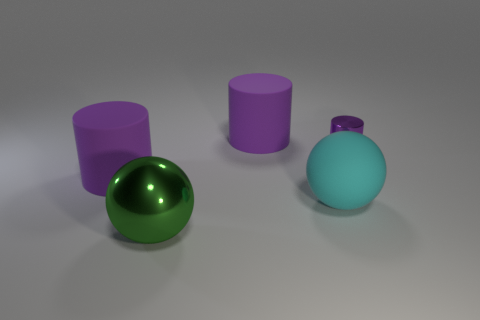There is a cyan rubber object; are there any cylinders to the left of it?
Ensure brevity in your answer.  Yes. How many other objects are the same shape as the tiny purple metal thing?
Offer a terse response. 2. The rubber ball that is the same size as the metal sphere is what color?
Provide a short and direct response. Cyan. Is the number of tiny purple things behind the green thing less than the number of purple cylinders that are to the left of the cyan thing?
Your answer should be compact. Yes. There is a big thing that is behind the big purple matte cylinder that is left of the green thing; what number of large things are left of it?
Make the answer very short. 2. What is the size of the cyan thing that is the same shape as the green metallic object?
Provide a short and direct response. Large. Is there anything else that is the same size as the purple shiny cylinder?
Your answer should be compact. No. Is the number of big purple cylinders that are to the right of the cyan sphere less than the number of green shiny objects?
Offer a very short reply. Yes. Do the green metal thing and the big cyan matte object have the same shape?
Your answer should be compact. Yes. What is the color of the large matte object that is the same shape as the big green metallic thing?
Provide a succinct answer. Cyan. 